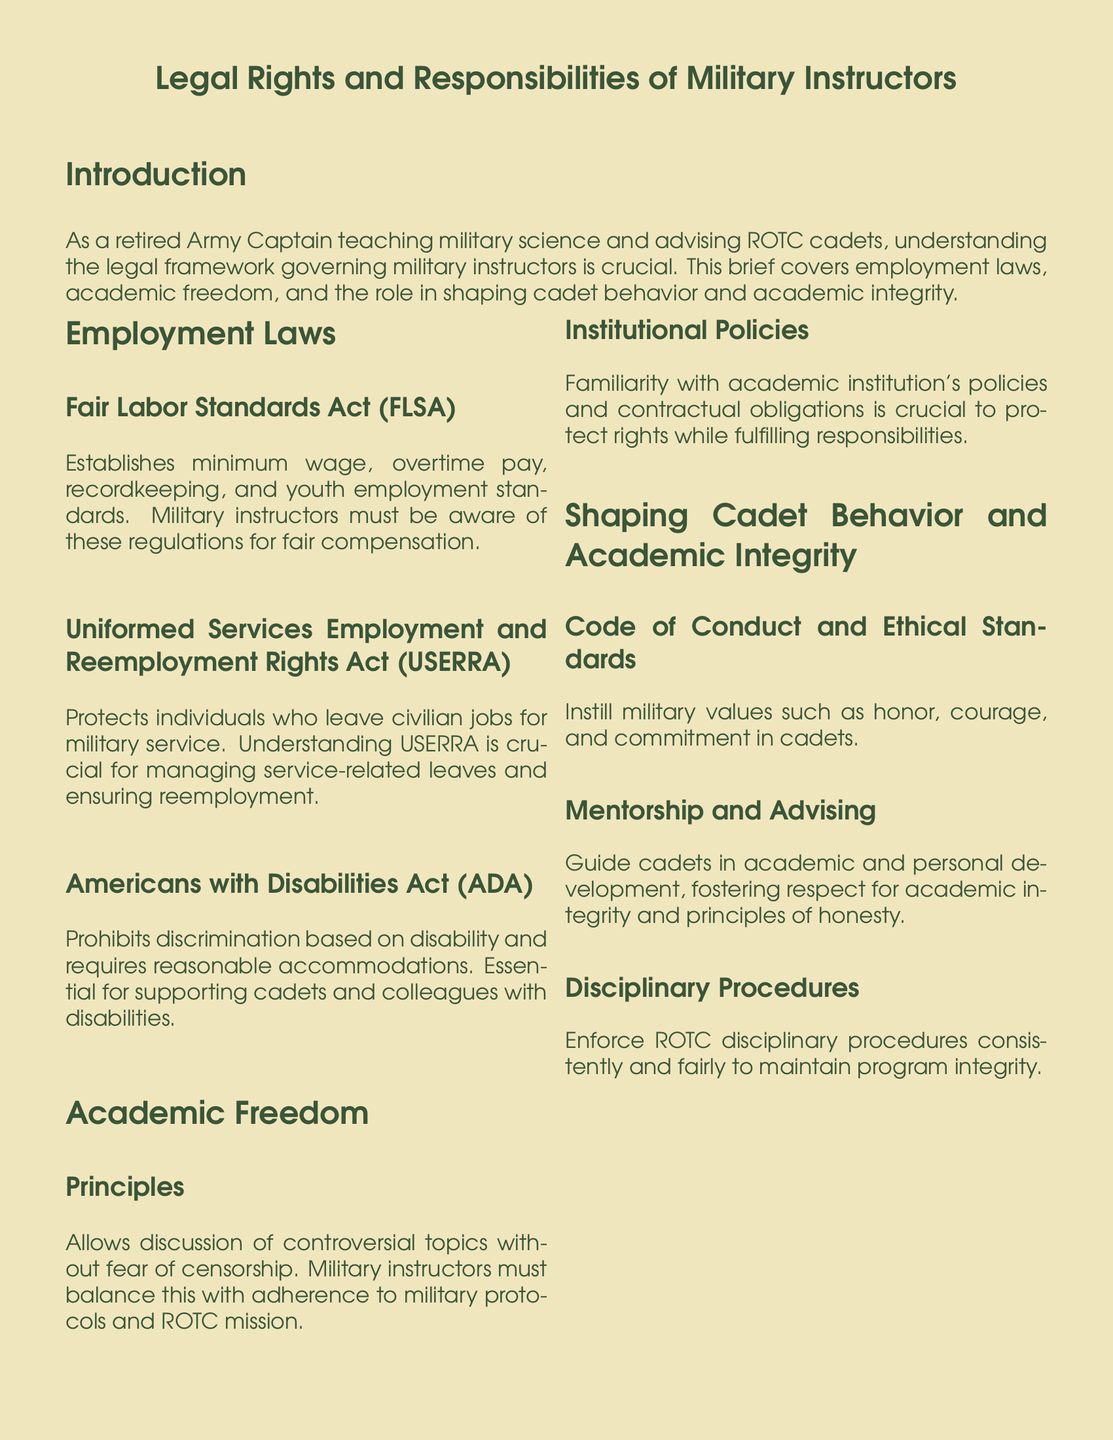What act establishes minimum wage and overtime pay? The Fair Labor Standards Act establishes minimum wage, overtime pay, recordkeeping, and youth employment standards.
Answer: Fair Labor Standards Act What does USERRA protect? The Uniformed Services Employment and Reemployment Rights Act protects individuals who leave civilian jobs for military service.
Answer: Reemployment rights What does the ADA prohibit? The Americans with Disabilities Act prohibits discrimination based on disability and requires reasonable accommodations.
Answer: Discrimination What is the key aspect of academic freedom mentioned? Academic freedom allows discussion of controversial topics without fear of censorship.
Answer: Censorship What values should military instructors instill in cadets? Military instructors should instill honor, courage, and commitment in cadets.
Answer: Military values What is a crucial responsibility of military instructors regarding mentorship? Military instructors guide cadets in academic and personal development.
Answer: Development guidance What do ROTC instructors enforce for program integrity? ROTC instructors enforce disciplinary procedures consistently and fairly.
Answer: Disciplinary procedures What is the legal responsibility of military instructors concerning institutional policies? Familiarity with institutional policies and contractual obligations is crucial.
Answer: Familiarity with policies What is the primary focus of this legal brief? The brief covers employment laws, academic freedom, and the role in shaping cadet behavior and academic integrity.
Answer: Legal rights and responsibilities of military instructors 